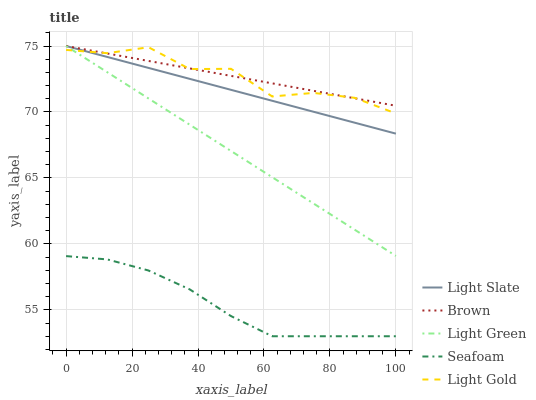Does Seafoam have the minimum area under the curve?
Answer yes or no. Yes. Does Brown have the maximum area under the curve?
Answer yes or no. Yes. Does Light Gold have the minimum area under the curve?
Answer yes or no. No. Does Light Gold have the maximum area under the curve?
Answer yes or no. No. Is Light Slate the smoothest?
Answer yes or no. Yes. Is Light Gold the roughest?
Answer yes or no. Yes. Is Light Gold the smoothest?
Answer yes or no. No. Is Brown the roughest?
Answer yes or no. No. Does Light Gold have the lowest value?
Answer yes or no. No. Does Light Green have the highest value?
Answer yes or no. Yes. Does Light Gold have the highest value?
Answer yes or no. No. Is Seafoam less than Brown?
Answer yes or no. Yes. Is Light Gold greater than Seafoam?
Answer yes or no. Yes. Does Light Gold intersect Brown?
Answer yes or no. Yes. Is Light Gold less than Brown?
Answer yes or no. No. Is Light Gold greater than Brown?
Answer yes or no. No. Does Seafoam intersect Brown?
Answer yes or no. No. 